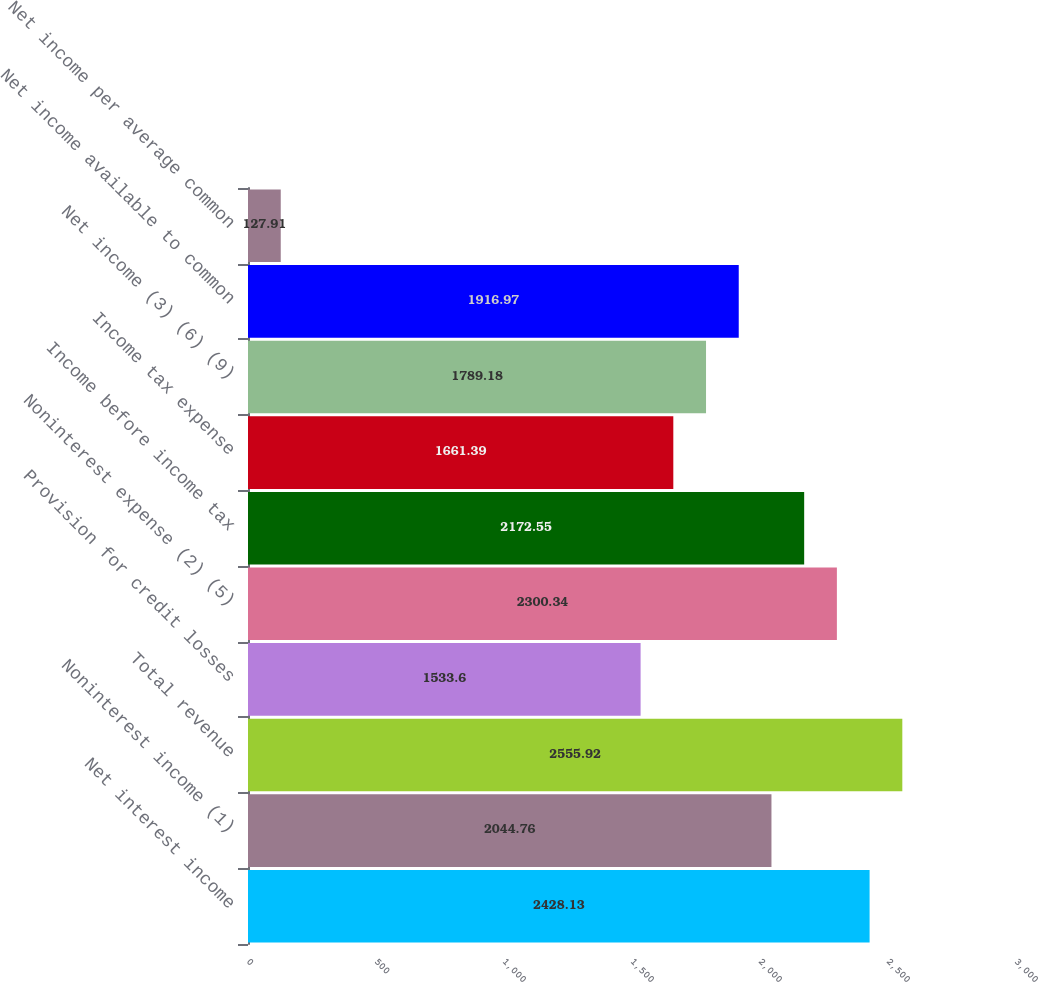Convert chart to OTSL. <chart><loc_0><loc_0><loc_500><loc_500><bar_chart><fcel>Net interest income<fcel>Noninterest income (1)<fcel>Total revenue<fcel>Provision for credit losses<fcel>Noninterest expense (2) (5)<fcel>Income before income tax<fcel>Income tax expense<fcel>Net income (3) (6) (9)<fcel>Net income available to common<fcel>Net income per average common<nl><fcel>2428.13<fcel>2044.76<fcel>2555.92<fcel>1533.6<fcel>2300.34<fcel>2172.55<fcel>1661.39<fcel>1789.18<fcel>1916.97<fcel>127.91<nl></chart> 